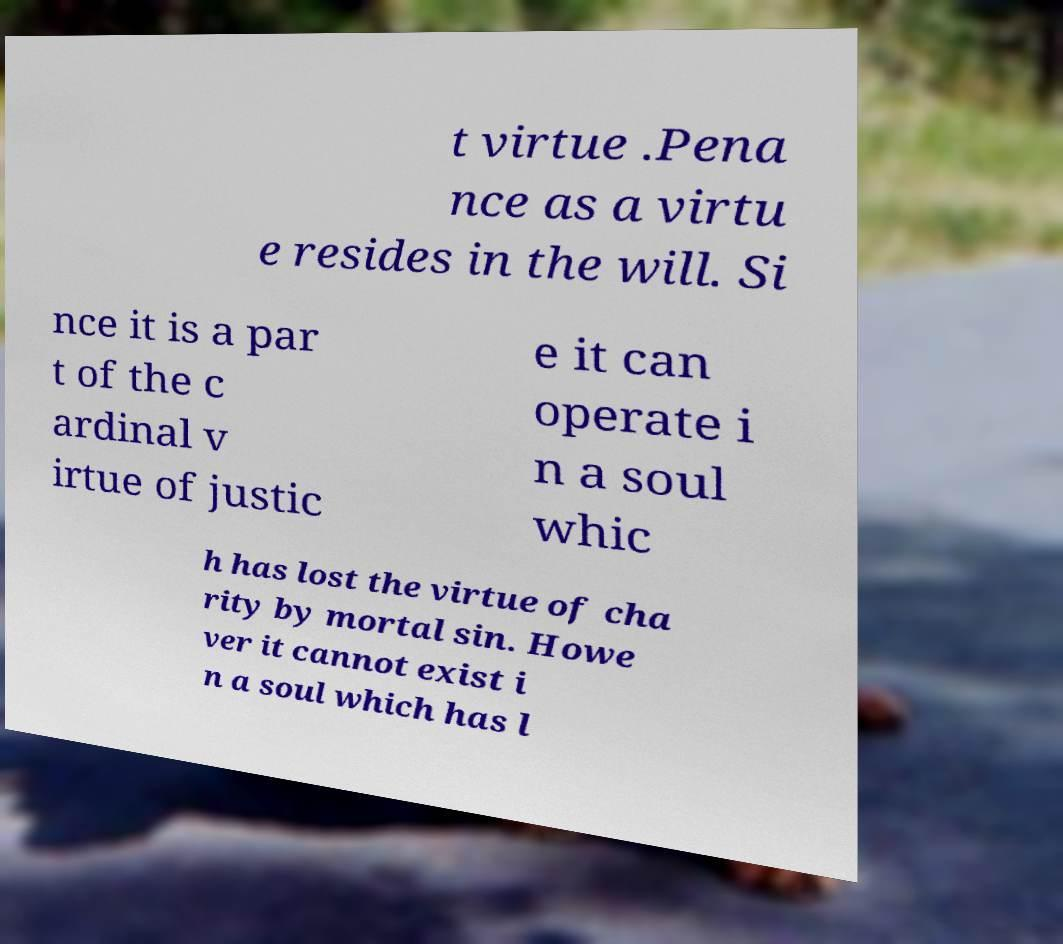Please read and relay the text visible in this image. What does it say? t virtue .Pena nce as a virtu e resides in the will. Si nce it is a par t of the c ardinal v irtue of justic e it can operate i n a soul whic h has lost the virtue of cha rity by mortal sin. Howe ver it cannot exist i n a soul which has l 